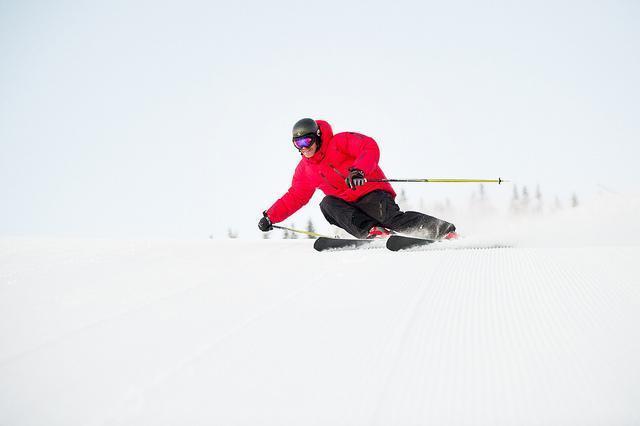How many orange trucks are there?
Give a very brief answer. 0. 